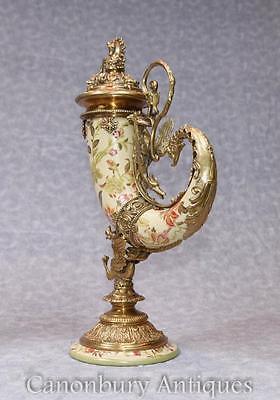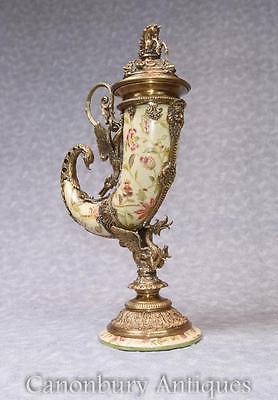The first image is the image on the left, the second image is the image on the right. For the images shown, is this caption "The vases in the two images have the same shape and color." true? Answer yes or no. Yes. 